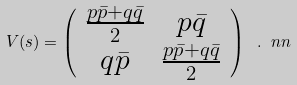Convert formula to latex. <formula><loc_0><loc_0><loc_500><loc_500>V ( s ) = \left ( \begin{array} { c c } \frac { p \bar { p } + q \bar { q } } { 2 } & p \bar { q } \\ q \bar { p } & \frac { p \bar { p } + q \bar { q } } { 2 } \end{array} \right ) \ . \ n n</formula> 